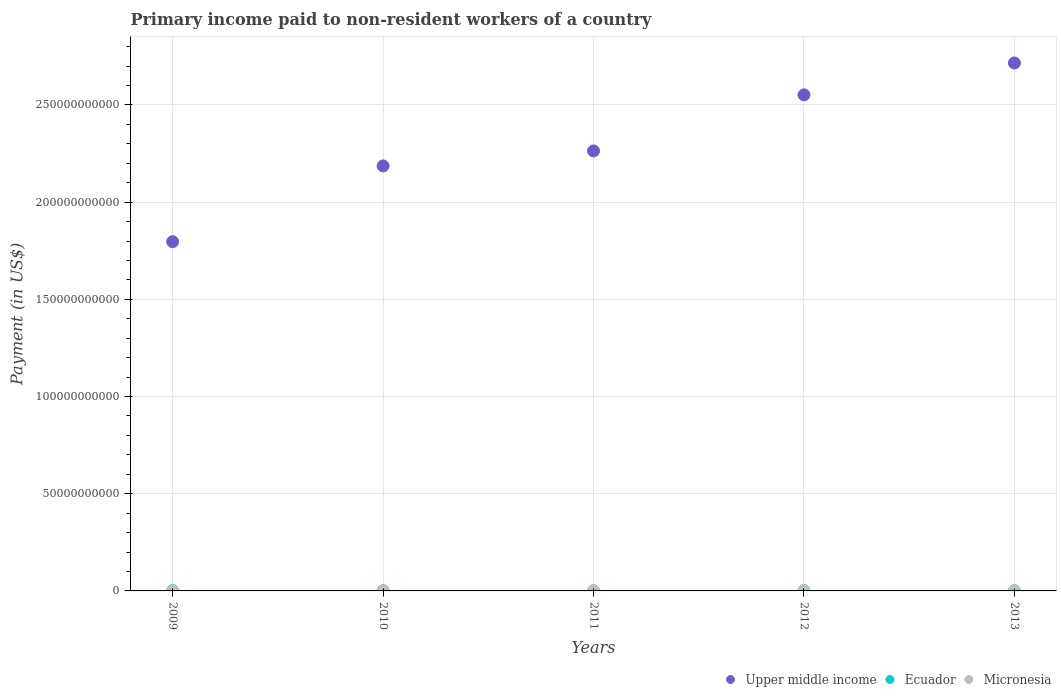Is the number of dotlines equal to the number of legend labels?
Make the answer very short. Yes. What is the amount paid to workers in Micronesia in 2010?
Provide a short and direct response. 2.35e+07. Across all years, what is the maximum amount paid to workers in Upper middle income?
Your answer should be compact. 2.72e+11. Across all years, what is the minimum amount paid to workers in Ecuador?
Offer a very short reply. 7.77e+07. In which year was the amount paid to workers in Ecuador maximum?
Give a very brief answer. 2009. In which year was the amount paid to workers in Upper middle income minimum?
Offer a terse response. 2009. What is the total amount paid to workers in Micronesia in the graph?
Your response must be concise. 1.45e+08. What is the difference between the amount paid to workers in Upper middle income in 2012 and that in 2013?
Ensure brevity in your answer.  -1.64e+1. What is the difference between the amount paid to workers in Upper middle income in 2013 and the amount paid to workers in Ecuador in 2010?
Ensure brevity in your answer.  2.72e+11. What is the average amount paid to workers in Micronesia per year?
Give a very brief answer. 2.90e+07. In the year 2009, what is the difference between the amount paid to workers in Micronesia and amount paid to workers in Ecuador?
Offer a very short reply. -1.72e+08. What is the ratio of the amount paid to workers in Micronesia in 2009 to that in 2011?
Give a very brief answer. 1.12. Is the amount paid to workers in Ecuador in 2010 less than that in 2012?
Your answer should be compact. Yes. What is the difference between the highest and the second highest amount paid to workers in Upper middle income?
Give a very brief answer. 1.64e+1. What is the difference between the highest and the lowest amount paid to workers in Micronesia?
Provide a short and direct response. 1.64e+07. In how many years, is the amount paid to workers in Upper middle income greater than the average amount paid to workers in Upper middle income taken over all years?
Your answer should be very brief. 2. Is it the case that in every year, the sum of the amount paid to workers in Upper middle income and amount paid to workers in Ecuador  is greater than the amount paid to workers in Micronesia?
Your response must be concise. Yes. Does the amount paid to workers in Upper middle income monotonically increase over the years?
Give a very brief answer. Yes. Is the amount paid to workers in Ecuador strictly greater than the amount paid to workers in Upper middle income over the years?
Offer a terse response. No. Is the amount paid to workers in Ecuador strictly less than the amount paid to workers in Micronesia over the years?
Keep it short and to the point. No. How many years are there in the graph?
Your response must be concise. 5. Does the graph contain grids?
Keep it short and to the point. Yes. Where does the legend appear in the graph?
Ensure brevity in your answer.  Bottom right. How are the legend labels stacked?
Make the answer very short. Horizontal. What is the title of the graph?
Your answer should be compact. Primary income paid to non-resident workers of a country. Does "Lebanon" appear as one of the legend labels in the graph?
Your response must be concise. No. What is the label or title of the X-axis?
Keep it short and to the point. Years. What is the label or title of the Y-axis?
Keep it short and to the point. Payment (in US$). What is the Payment (in US$) of Upper middle income in 2009?
Provide a short and direct response. 1.80e+11. What is the Payment (in US$) in Ecuador in 2009?
Offer a very short reply. 1.99e+08. What is the Payment (in US$) in Micronesia in 2009?
Offer a terse response. 2.66e+07. What is the Payment (in US$) of Upper middle income in 2010?
Ensure brevity in your answer.  2.19e+11. What is the Payment (in US$) of Ecuador in 2010?
Your answer should be very brief. 7.77e+07. What is the Payment (in US$) of Micronesia in 2010?
Your response must be concise. 2.35e+07. What is the Payment (in US$) of Upper middle income in 2011?
Offer a terse response. 2.26e+11. What is the Payment (in US$) of Ecuador in 2011?
Make the answer very short. 8.45e+07. What is the Payment (in US$) in Micronesia in 2011?
Ensure brevity in your answer.  2.37e+07. What is the Payment (in US$) of Upper middle income in 2012?
Make the answer very short. 2.55e+11. What is the Payment (in US$) of Ecuador in 2012?
Provide a short and direct response. 1.05e+08. What is the Payment (in US$) of Micronesia in 2012?
Make the answer very short. 3.14e+07. What is the Payment (in US$) in Upper middle income in 2013?
Offer a very short reply. 2.72e+11. What is the Payment (in US$) in Ecuador in 2013?
Your answer should be very brief. 1.13e+08. What is the Payment (in US$) in Micronesia in 2013?
Ensure brevity in your answer.  3.99e+07. Across all years, what is the maximum Payment (in US$) in Upper middle income?
Give a very brief answer. 2.72e+11. Across all years, what is the maximum Payment (in US$) of Ecuador?
Keep it short and to the point. 1.99e+08. Across all years, what is the maximum Payment (in US$) in Micronesia?
Your response must be concise. 3.99e+07. Across all years, what is the minimum Payment (in US$) in Upper middle income?
Offer a very short reply. 1.80e+11. Across all years, what is the minimum Payment (in US$) of Ecuador?
Give a very brief answer. 7.77e+07. Across all years, what is the minimum Payment (in US$) of Micronesia?
Provide a succinct answer. 2.35e+07. What is the total Payment (in US$) in Upper middle income in the graph?
Provide a short and direct response. 1.15e+12. What is the total Payment (in US$) in Ecuador in the graph?
Provide a short and direct response. 5.79e+08. What is the total Payment (in US$) of Micronesia in the graph?
Provide a succinct answer. 1.45e+08. What is the difference between the Payment (in US$) of Upper middle income in 2009 and that in 2010?
Make the answer very short. -3.90e+1. What is the difference between the Payment (in US$) of Ecuador in 2009 and that in 2010?
Make the answer very short. 1.21e+08. What is the difference between the Payment (in US$) of Micronesia in 2009 and that in 2010?
Offer a very short reply. 3.11e+06. What is the difference between the Payment (in US$) in Upper middle income in 2009 and that in 2011?
Ensure brevity in your answer.  -4.67e+1. What is the difference between the Payment (in US$) of Ecuador in 2009 and that in 2011?
Provide a succinct answer. 1.15e+08. What is the difference between the Payment (in US$) in Micronesia in 2009 and that in 2011?
Keep it short and to the point. 2.86e+06. What is the difference between the Payment (in US$) of Upper middle income in 2009 and that in 2012?
Provide a succinct answer. -7.55e+1. What is the difference between the Payment (in US$) in Ecuador in 2009 and that in 2012?
Your answer should be very brief. 9.38e+07. What is the difference between the Payment (in US$) in Micronesia in 2009 and that in 2012?
Provide a short and direct response. -4.83e+06. What is the difference between the Payment (in US$) in Upper middle income in 2009 and that in 2013?
Give a very brief answer. -9.19e+1. What is the difference between the Payment (in US$) in Ecuador in 2009 and that in 2013?
Offer a terse response. 8.64e+07. What is the difference between the Payment (in US$) in Micronesia in 2009 and that in 2013?
Give a very brief answer. -1.33e+07. What is the difference between the Payment (in US$) in Upper middle income in 2010 and that in 2011?
Your answer should be compact. -7.73e+09. What is the difference between the Payment (in US$) of Ecuador in 2010 and that in 2011?
Your response must be concise. -6.75e+06. What is the difference between the Payment (in US$) in Micronesia in 2010 and that in 2011?
Ensure brevity in your answer.  -2.48e+05. What is the difference between the Payment (in US$) of Upper middle income in 2010 and that in 2012?
Provide a succinct answer. -3.66e+1. What is the difference between the Payment (in US$) of Ecuador in 2010 and that in 2012?
Your answer should be very brief. -2.76e+07. What is the difference between the Payment (in US$) of Micronesia in 2010 and that in 2012?
Your answer should be very brief. -7.94e+06. What is the difference between the Payment (in US$) in Upper middle income in 2010 and that in 2013?
Offer a very short reply. -5.30e+1. What is the difference between the Payment (in US$) of Ecuador in 2010 and that in 2013?
Offer a terse response. -3.49e+07. What is the difference between the Payment (in US$) of Micronesia in 2010 and that in 2013?
Provide a short and direct response. -1.64e+07. What is the difference between the Payment (in US$) in Upper middle income in 2011 and that in 2012?
Keep it short and to the point. -2.88e+1. What is the difference between the Payment (in US$) in Ecuador in 2011 and that in 2012?
Provide a short and direct response. -2.08e+07. What is the difference between the Payment (in US$) in Micronesia in 2011 and that in 2012?
Your answer should be very brief. -7.70e+06. What is the difference between the Payment (in US$) in Upper middle income in 2011 and that in 2013?
Offer a terse response. -4.52e+1. What is the difference between the Payment (in US$) in Ecuador in 2011 and that in 2013?
Give a very brief answer. -2.82e+07. What is the difference between the Payment (in US$) in Micronesia in 2011 and that in 2013?
Provide a short and direct response. -1.61e+07. What is the difference between the Payment (in US$) of Upper middle income in 2012 and that in 2013?
Keep it short and to the point. -1.64e+1. What is the difference between the Payment (in US$) in Ecuador in 2012 and that in 2013?
Ensure brevity in your answer.  -7.33e+06. What is the difference between the Payment (in US$) in Micronesia in 2012 and that in 2013?
Offer a very short reply. -8.44e+06. What is the difference between the Payment (in US$) of Upper middle income in 2009 and the Payment (in US$) of Ecuador in 2010?
Give a very brief answer. 1.80e+11. What is the difference between the Payment (in US$) in Upper middle income in 2009 and the Payment (in US$) in Micronesia in 2010?
Keep it short and to the point. 1.80e+11. What is the difference between the Payment (in US$) in Ecuador in 2009 and the Payment (in US$) in Micronesia in 2010?
Provide a short and direct response. 1.76e+08. What is the difference between the Payment (in US$) of Upper middle income in 2009 and the Payment (in US$) of Ecuador in 2011?
Give a very brief answer. 1.80e+11. What is the difference between the Payment (in US$) in Upper middle income in 2009 and the Payment (in US$) in Micronesia in 2011?
Your answer should be compact. 1.80e+11. What is the difference between the Payment (in US$) of Ecuador in 2009 and the Payment (in US$) of Micronesia in 2011?
Keep it short and to the point. 1.75e+08. What is the difference between the Payment (in US$) of Upper middle income in 2009 and the Payment (in US$) of Ecuador in 2012?
Offer a very short reply. 1.80e+11. What is the difference between the Payment (in US$) in Upper middle income in 2009 and the Payment (in US$) in Micronesia in 2012?
Give a very brief answer. 1.80e+11. What is the difference between the Payment (in US$) of Ecuador in 2009 and the Payment (in US$) of Micronesia in 2012?
Give a very brief answer. 1.68e+08. What is the difference between the Payment (in US$) of Upper middle income in 2009 and the Payment (in US$) of Ecuador in 2013?
Provide a short and direct response. 1.80e+11. What is the difference between the Payment (in US$) in Upper middle income in 2009 and the Payment (in US$) in Micronesia in 2013?
Provide a short and direct response. 1.80e+11. What is the difference between the Payment (in US$) in Ecuador in 2009 and the Payment (in US$) in Micronesia in 2013?
Give a very brief answer. 1.59e+08. What is the difference between the Payment (in US$) of Upper middle income in 2010 and the Payment (in US$) of Ecuador in 2011?
Provide a short and direct response. 2.19e+11. What is the difference between the Payment (in US$) in Upper middle income in 2010 and the Payment (in US$) in Micronesia in 2011?
Offer a very short reply. 2.19e+11. What is the difference between the Payment (in US$) of Ecuador in 2010 and the Payment (in US$) of Micronesia in 2011?
Your response must be concise. 5.40e+07. What is the difference between the Payment (in US$) in Upper middle income in 2010 and the Payment (in US$) in Ecuador in 2012?
Your response must be concise. 2.19e+11. What is the difference between the Payment (in US$) in Upper middle income in 2010 and the Payment (in US$) in Micronesia in 2012?
Your answer should be compact. 2.19e+11. What is the difference between the Payment (in US$) in Ecuador in 2010 and the Payment (in US$) in Micronesia in 2012?
Provide a short and direct response. 4.63e+07. What is the difference between the Payment (in US$) in Upper middle income in 2010 and the Payment (in US$) in Ecuador in 2013?
Your response must be concise. 2.19e+11. What is the difference between the Payment (in US$) in Upper middle income in 2010 and the Payment (in US$) in Micronesia in 2013?
Provide a short and direct response. 2.19e+11. What is the difference between the Payment (in US$) in Ecuador in 2010 and the Payment (in US$) in Micronesia in 2013?
Your response must be concise. 3.78e+07. What is the difference between the Payment (in US$) in Upper middle income in 2011 and the Payment (in US$) in Ecuador in 2012?
Your answer should be compact. 2.26e+11. What is the difference between the Payment (in US$) in Upper middle income in 2011 and the Payment (in US$) in Micronesia in 2012?
Keep it short and to the point. 2.26e+11. What is the difference between the Payment (in US$) in Ecuador in 2011 and the Payment (in US$) in Micronesia in 2012?
Offer a terse response. 5.30e+07. What is the difference between the Payment (in US$) of Upper middle income in 2011 and the Payment (in US$) of Ecuador in 2013?
Offer a terse response. 2.26e+11. What is the difference between the Payment (in US$) in Upper middle income in 2011 and the Payment (in US$) in Micronesia in 2013?
Provide a short and direct response. 2.26e+11. What is the difference between the Payment (in US$) of Ecuador in 2011 and the Payment (in US$) of Micronesia in 2013?
Give a very brief answer. 4.46e+07. What is the difference between the Payment (in US$) in Upper middle income in 2012 and the Payment (in US$) in Ecuador in 2013?
Your answer should be compact. 2.55e+11. What is the difference between the Payment (in US$) in Upper middle income in 2012 and the Payment (in US$) in Micronesia in 2013?
Your answer should be very brief. 2.55e+11. What is the difference between the Payment (in US$) in Ecuador in 2012 and the Payment (in US$) in Micronesia in 2013?
Provide a succinct answer. 6.54e+07. What is the average Payment (in US$) of Upper middle income per year?
Provide a succinct answer. 2.30e+11. What is the average Payment (in US$) in Ecuador per year?
Offer a terse response. 1.16e+08. What is the average Payment (in US$) in Micronesia per year?
Your answer should be very brief. 2.90e+07. In the year 2009, what is the difference between the Payment (in US$) in Upper middle income and Payment (in US$) in Ecuador?
Your answer should be very brief. 1.79e+11. In the year 2009, what is the difference between the Payment (in US$) in Upper middle income and Payment (in US$) in Micronesia?
Your answer should be very brief. 1.80e+11. In the year 2009, what is the difference between the Payment (in US$) in Ecuador and Payment (in US$) in Micronesia?
Keep it short and to the point. 1.72e+08. In the year 2010, what is the difference between the Payment (in US$) in Upper middle income and Payment (in US$) in Ecuador?
Give a very brief answer. 2.19e+11. In the year 2010, what is the difference between the Payment (in US$) in Upper middle income and Payment (in US$) in Micronesia?
Offer a very short reply. 2.19e+11. In the year 2010, what is the difference between the Payment (in US$) in Ecuador and Payment (in US$) in Micronesia?
Your answer should be compact. 5.42e+07. In the year 2011, what is the difference between the Payment (in US$) of Upper middle income and Payment (in US$) of Ecuador?
Make the answer very short. 2.26e+11. In the year 2011, what is the difference between the Payment (in US$) in Upper middle income and Payment (in US$) in Micronesia?
Provide a succinct answer. 2.26e+11. In the year 2011, what is the difference between the Payment (in US$) in Ecuador and Payment (in US$) in Micronesia?
Provide a succinct answer. 6.07e+07. In the year 2012, what is the difference between the Payment (in US$) of Upper middle income and Payment (in US$) of Ecuador?
Keep it short and to the point. 2.55e+11. In the year 2012, what is the difference between the Payment (in US$) of Upper middle income and Payment (in US$) of Micronesia?
Your response must be concise. 2.55e+11. In the year 2012, what is the difference between the Payment (in US$) of Ecuador and Payment (in US$) of Micronesia?
Your answer should be very brief. 7.39e+07. In the year 2013, what is the difference between the Payment (in US$) of Upper middle income and Payment (in US$) of Ecuador?
Provide a short and direct response. 2.71e+11. In the year 2013, what is the difference between the Payment (in US$) in Upper middle income and Payment (in US$) in Micronesia?
Give a very brief answer. 2.72e+11. In the year 2013, what is the difference between the Payment (in US$) in Ecuador and Payment (in US$) in Micronesia?
Your answer should be very brief. 7.28e+07. What is the ratio of the Payment (in US$) in Upper middle income in 2009 to that in 2010?
Provide a short and direct response. 0.82. What is the ratio of the Payment (in US$) in Ecuador in 2009 to that in 2010?
Provide a succinct answer. 2.56. What is the ratio of the Payment (in US$) of Micronesia in 2009 to that in 2010?
Make the answer very short. 1.13. What is the ratio of the Payment (in US$) of Upper middle income in 2009 to that in 2011?
Offer a very short reply. 0.79. What is the ratio of the Payment (in US$) of Ecuador in 2009 to that in 2011?
Your response must be concise. 2.36. What is the ratio of the Payment (in US$) in Micronesia in 2009 to that in 2011?
Your response must be concise. 1.12. What is the ratio of the Payment (in US$) in Upper middle income in 2009 to that in 2012?
Provide a succinct answer. 0.7. What is the ratio of the Payment (in US$) of Ecuador in 2009 to that in 2012?
Your answer should be compact. 1.89. What is the ratio of the Payment (in US$) of Micronesia in 2009 to that in 2012?
Provide a succinct answer. 0.85. What is the ratio of the Payment (in US$) in Upper middle income in 2009 to that in 2013?
Offer a very short reply. 0.66. What is the ratio of the Payment (in US$) of Ecuador in 2009 to that in 2013?
Ensure brevity in your answer.  1.77. What is the ratio of the Payment (in US$) of Micronesia in 2009 to that in 2013?
Your answer should be very brief. 0.67. What is the ratio of the Payment (in US$) of Upper middle income in 2010 to that in 2011?
Ensure brevity in your answer.  0.97. What is the ratio of the Payment (in US$) of Ecuador in 2010 to that in 2011?
Keep it short and to the point. 0.92. What is the ratio of the Payment (in US$) in Micronesia in 2010 to that in 2011?
Give a very brief answer. 0.99. What is the ratio of the Payment (in US$) of Upper middle income in 2010 to that in 2012?
Your answer should be compact. 0.86. What is the ratio of the Payment (in US$) in Ecuador in 2010 to that in 2012?
Make the answer very short. 0.74. What is the ratio of the Payment (in US$) in Micronesia in 2010 to that in 2012?
Make the answer very short. 0.75. What is the ratio of the Payment (in US$) of Upper middle income in 2010 to that in 2013?
Provide a short and direct response. 0.81. What is the ratio of the Payment (in US$) in Ecuador in 2010 to that in 2013?
Your answer should be very brief. 0.69. What is the ratio of the Payment (in US$) of Micronesia in 2010 to that in 2013?
Offer a very short reply. 0.59. What is the ratio of the Payment (in US$) of Upper middle income in 2011 to that in 2012?
Offer a very short reply. 0.89. What is the ratio of the Payment (in US$) in Ecuador in 2011 to that in 2012?
Keep it short and to the point. 0.8. What is the ratio of the Payment (in US$) of Micronesia in 2011 to that in 2012?
Keep it short and to the point. 0.76. What is the ratio of the Payment (in US$) in Upper middle income in 2011 to that in 2013?
Ensure brevity in your answer.  0.83. What is the ratio of the Payment (in US$) of Ecuador in 2011 to that in 2013?
Keep it short and to the point. 0.75. What is the ratio of the Payment (in US$) in Micronesia in 2011 to that in 2013?
Keep it short and to the point. 0.6. What is the ratio of the Payment (in US$) in Upper middle income in 2012 to that in 2013?
Provide a short and direct response. 0.94. What is the ratio of the Payment (in US$) in Ecuador in 2012 to that in 2013?
Ensure brevity in your answer.  0.94. What is the ratio of the Payment (in US$) in Micronesia in 2012 to that in 2013?
Make the answer very short. 0.79. What is the difference between the highest and the second highest Payment (in US$) in Upper middle income?
Your answer should be compact. 1.64e+1. What is the difference between the highest and the second highest Payment (in US$) of Ecuador?
Your answer should be compact. 8.64e+07. What is the difference between the highest and the second highest Payment (in US$) in Micronesia?
Your response must be concise. 8.44e+06. What is the difference between the highest and the lowest Payment (in US$) of Upper middle income?
Keep it short and to the point. 9.19e+1. What is the difference between the highest and the lowest Payment (in US$) in Ecuador?
Keep it short and to the point. 1.21e+08. What is the difference between the highest and the lowest Payment (in US$) in Micronesia?
Your answer should be compact. 1.64e+07. 